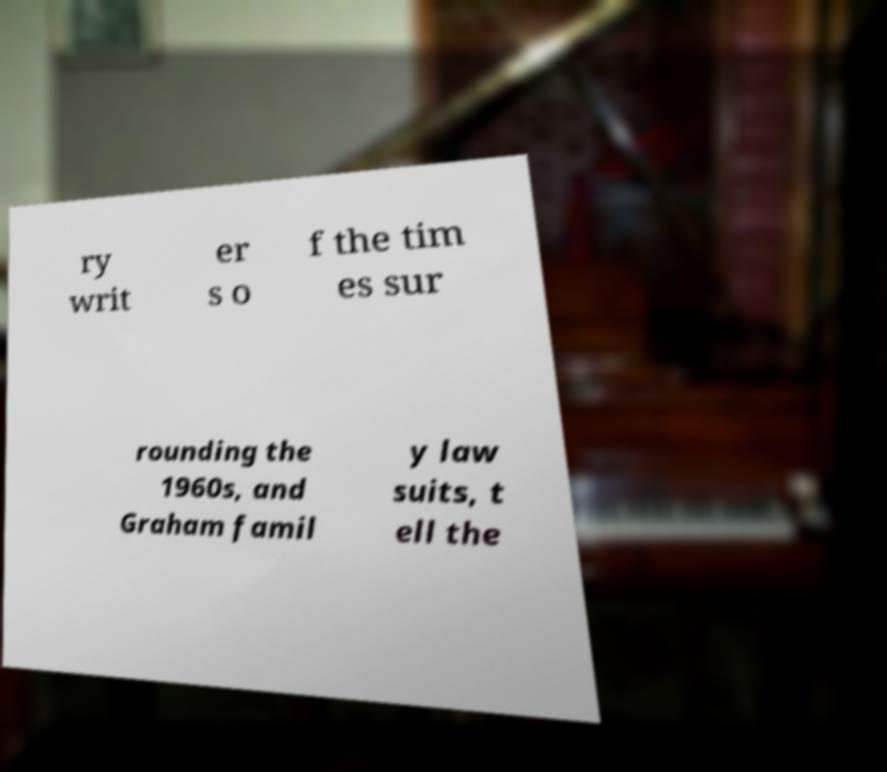Can you accurately transcribe the text from the provided image for me? ry writ er s o f the tim es sur rounding the 1960s, and Graham famil y law suits, t ell the 